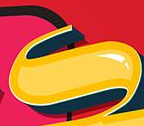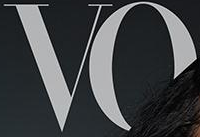What words can you see in these images in sequence, separated by a semicolon? s; VO 